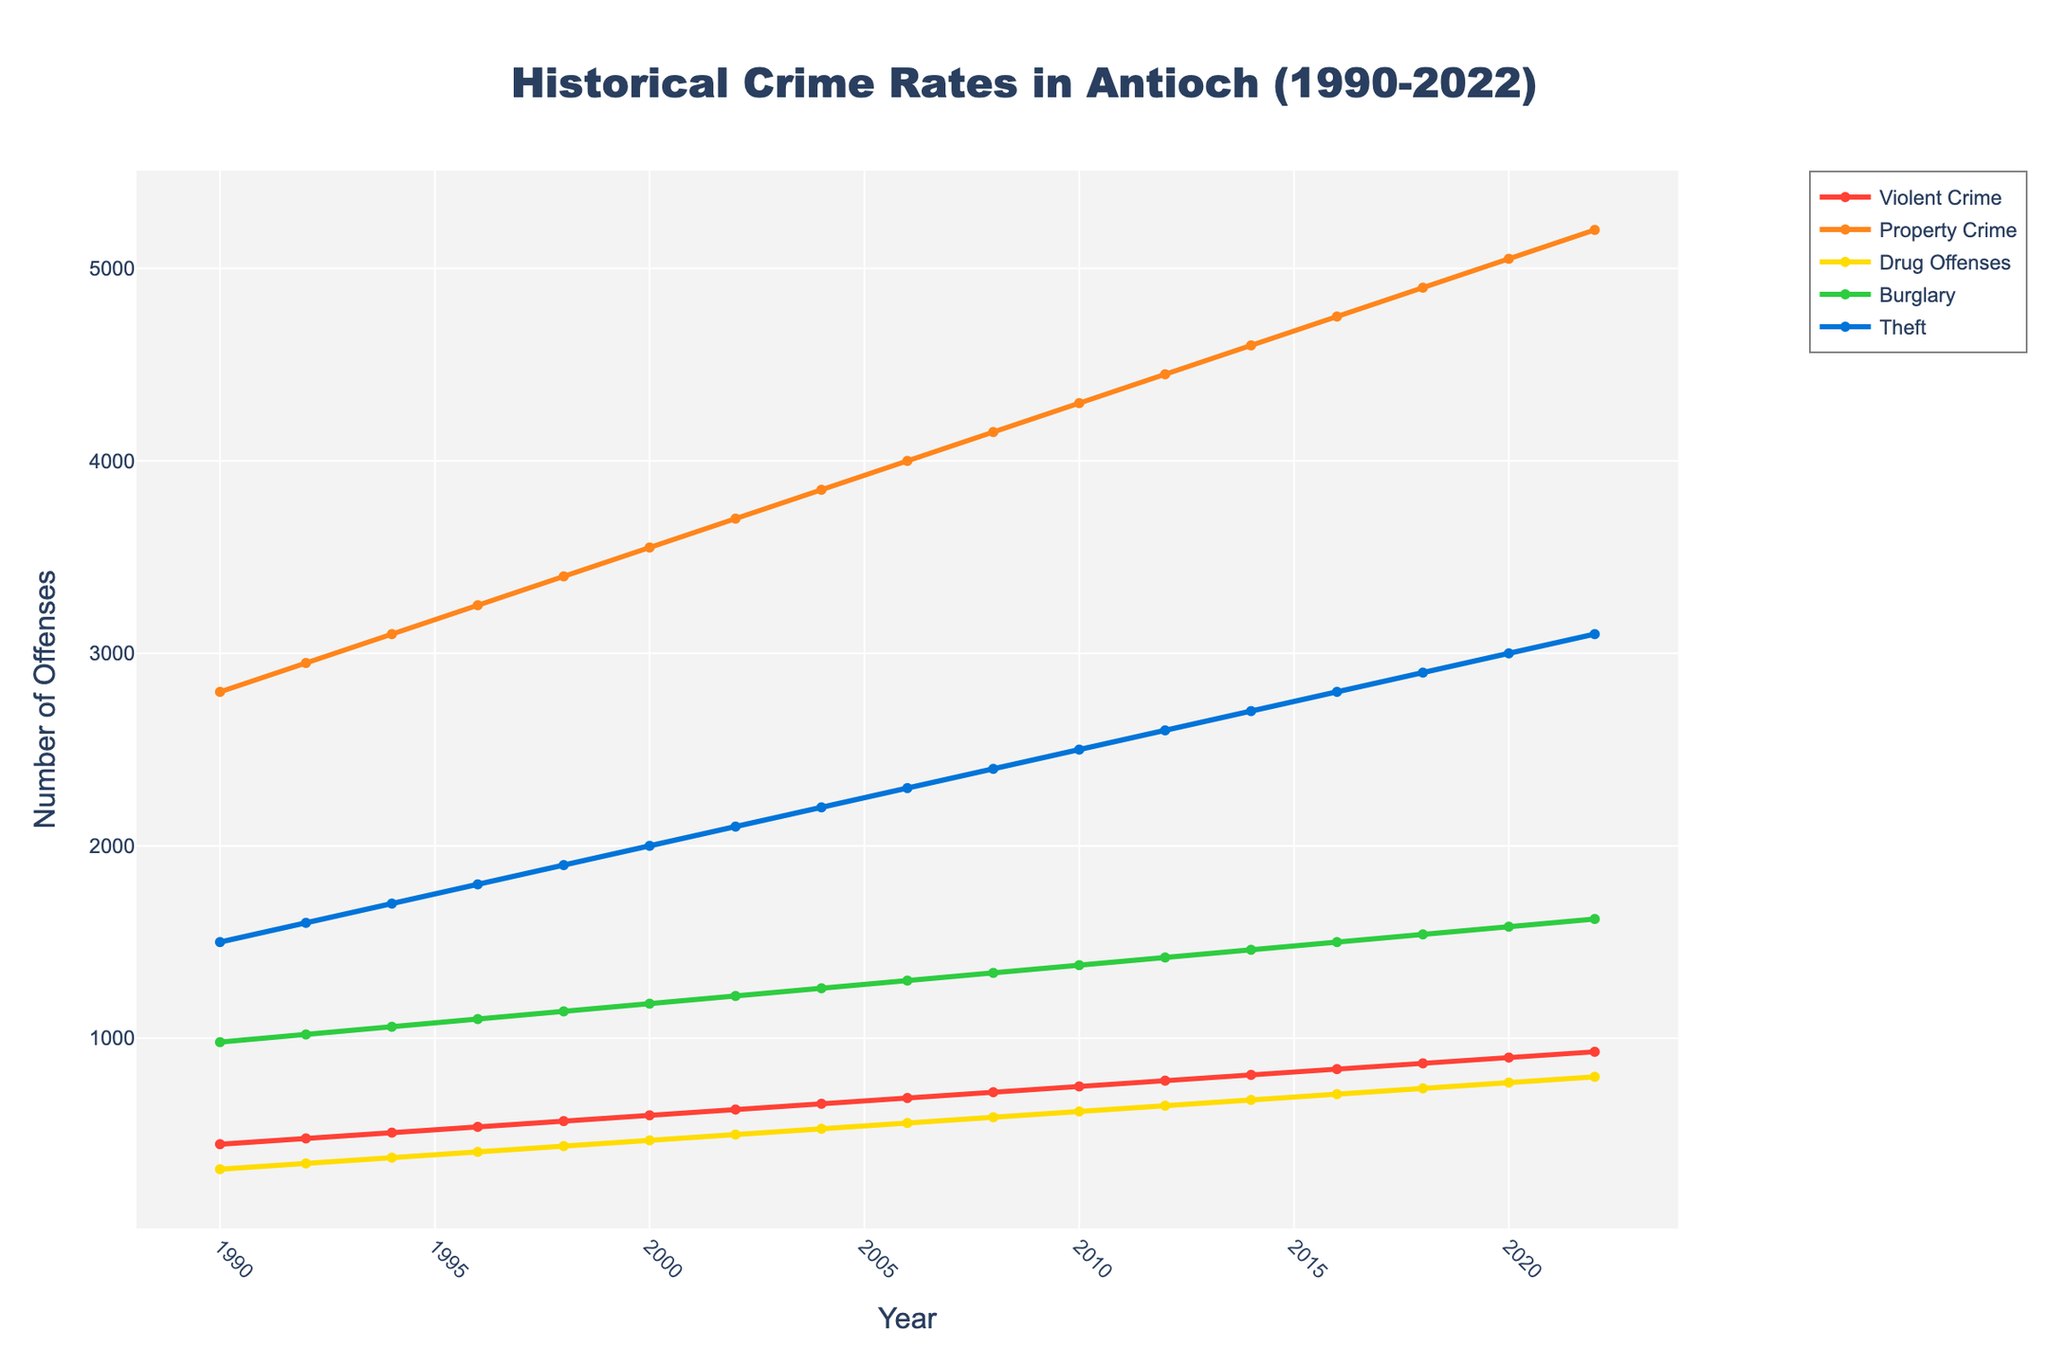What is the trend in Violent Crime from 1990 to 2022? Violent Crime increases consistently from 450 incidents in 1990 to 930 incidents in 2022.
Answer: Increasing trend Which type of crime had the highest rate in 1990? In 1990, Property Crime had the highest rate with 2800 incidents compared to other crime types.
Answer: Property Crime By how much has the number of Drug Offenses increased from 1990 to 2022? The number of Drug Offenses in 1990 was 320, and it increased to 800 in 2022. The increase is calculated as 800 - 320 = 480.
Answer: 480 Which crime type experienced the smallest percentage increase from 1990 to 2022? Calculate the percentage increase for each crime type: Violent Crime [(930-450)/450] = 106.7%, Property Crime [(5200-2800)/2800] = 85.7%, Drug Offenses [(800-320)/320] = 150%, Burglary [(1620-980)/980] = 65.3%, Theft [(3100-1500)/1500] = 106.7%. Burglary has the smallest percentage increase.
Answer: Burglary Which year experienced the highest number of Property Crimes? Property Crime peaked at 5200 incidents in the year 2022 as indicated by the highest point of the Property Crime line on the plot.
Answer: 2022 Has the rate of Burglary ever decreased over a two-year period? Visual inspection of the Burglary trend line shows a continuous increase from 980 in 1990 to 1620 in 2022, with no decrease in any two-year interval.
Answer: No Compare the trends of Violent Crime and Burglary. Violent Crime steadily increases from 450 in 1990 to 930 in 2022. Burglary also increases but starts from a higher base (980) and ends at 1620 in 2022. Both crime types exhibit a steady upward trend, albeit Burglary increases at a slightly slower rate.
Answer: Both have increasing trends What year did Theft surpass 2000 incidents? According to the trend line for Theft, it surpassed 2000 incidents in the year 2000, reaching 2000 in that year.
Answer: 2000 How much higher is the number of Property Crimes compared to Violent Crimes in 2022? In 2022, Property Crimes are 5200, and Violent Crimes are 930. The difference is 5200 - 930 = 4270.
Answer: 4270 What is the color representing Drug Offenses in the chart? The line representing Drug Offenses in the chart is colored yellow, which can be confirmed by the visual attributes of the plotted figure.
Answer: Yellow 